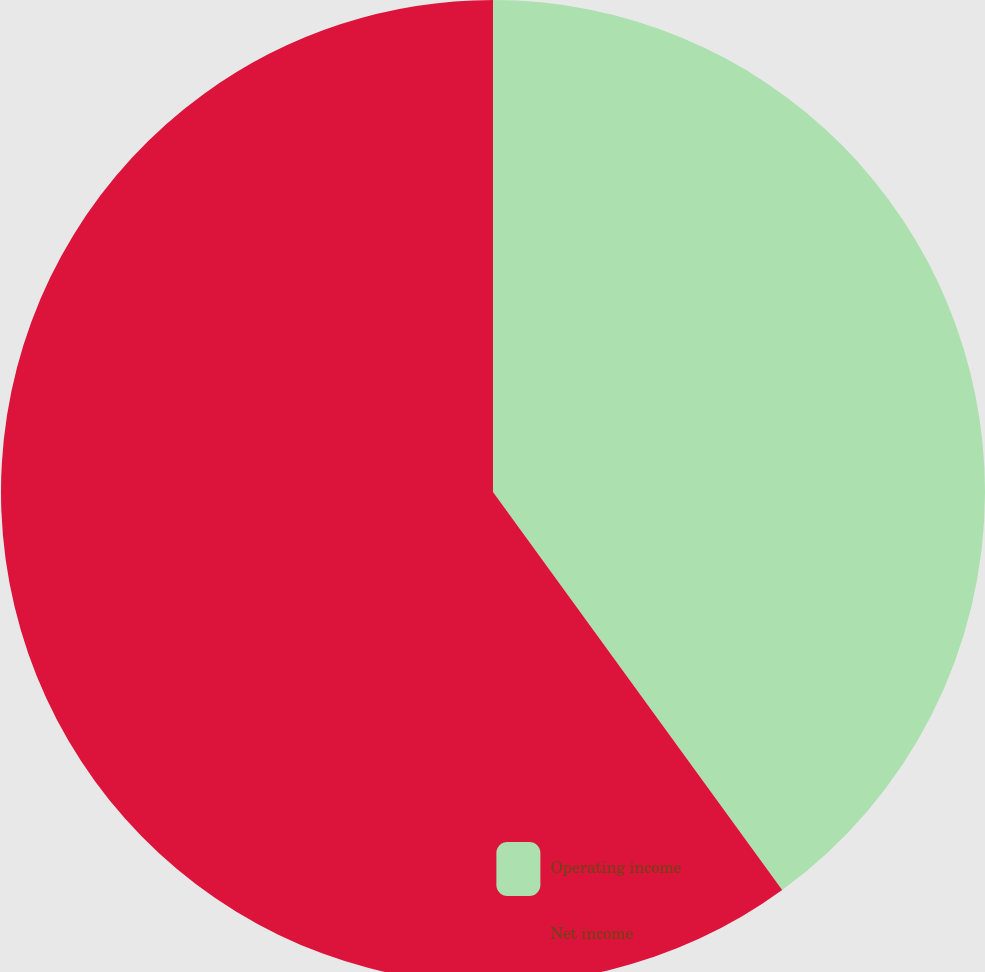Convert chart to OTSL. <chart><loc_0><loc_0><loc_500><loc_500><pie_chart><fcel>Operating income<fcel>Net income<nl><fcel>40.0%<fcel>60.0%<nl></chart> 